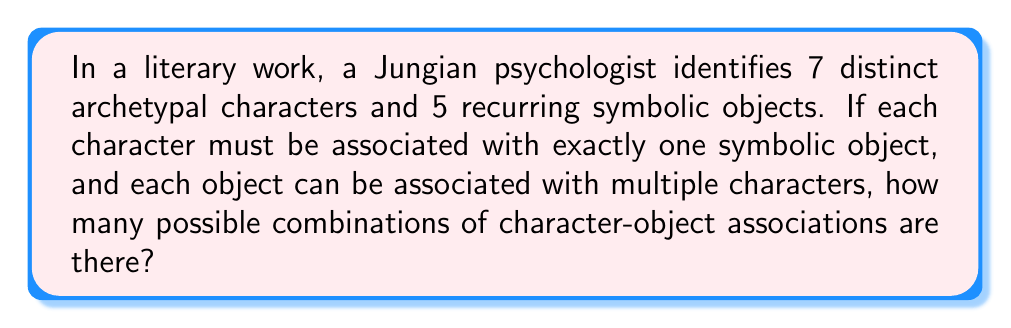Show me your answer to this math problem. Let's approach this step-by-step:

1) We have 7 characters, each of which must be assigned to one of the 5 objects.

2) This scenario can be viewed as a function from the set of characters to the set of objects.

3) In mathematical terms, we're looking for the number of possible functions from a set of 7 elements to a set of 5 elements.

4) The number of such functions is given by the formula:

   $$n^r$$

   Where $n$ is the number of elements in the codomain (objects in this case) and $r$ is the number of elements in the domain (characters in this case).

5) Plugging in our values:

   $$5^7$$

6) Calculate:
   
   $$5^7 = 5 \times 5 \times 5 \times 5 \times 5 \times 5 \times 5 = 78,125$$

Therefore, there are 78,125 possible combinations of character-object associations in this literary work.
Answer: $5^7 = 78,125$ 